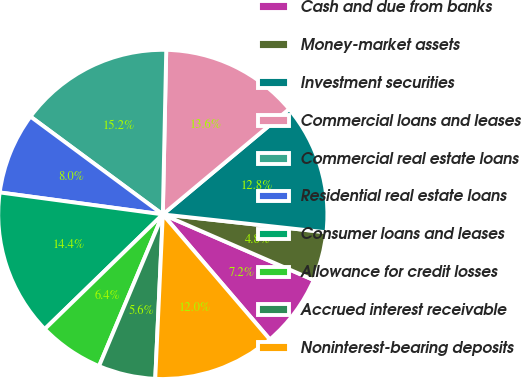<chart> <loc_0><loc_0><loc_500><loc_500><pie_chart><fcel>Cash and due from banks<fcel>Money-market assets<fcel>Investment securities<fcel>Commercial loans and leases<fcel>Commercial real estate loans<fcel>Residential real estate loans<fcel>Consumer loans and leases<fcel>Allowance for credit losses<fcel>Accrued interest receivable<fcel>Noninterest-bearing deposits<nl><fcel>7.2%<fcel>4.8%<fcel>12.8%<fcel>13.6%<fcel>15.2%<fcel>8.0%<fcel>14.4%<fcel>6.4%<fcel>5.6%<fcel>12.0%<nl></chart> 